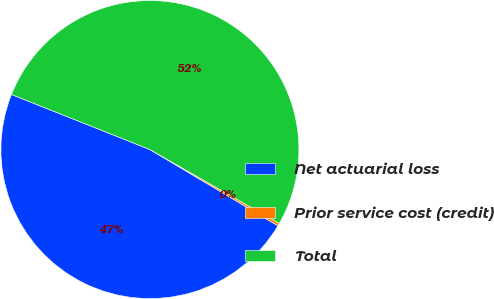Convert chart. <chart><loc_0><loc_0><loc_500><loc_500><pie_chart><fcel>Net actuarial loss<fcel>Prior service cost (credit)<fcel>Total<nl><fcel>47.48%<fcel>0.29%<fcel>52.23%<nl></chart> 